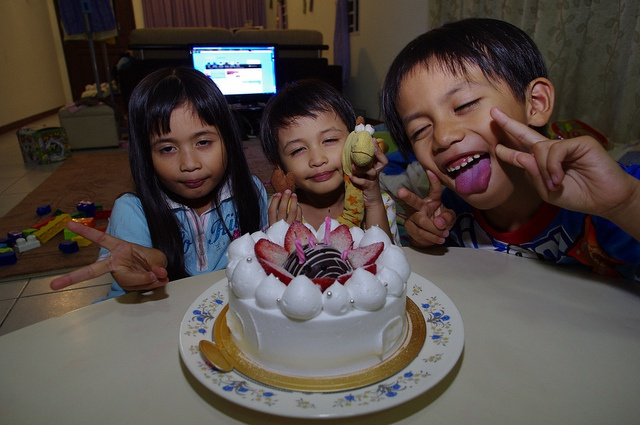Describe the objects in this image and their specific colors. I can see dining table in maroon, gray, black, and olive tones, people in maroon, black, gray, and brown tones, people in maroon, black, and gray tones, cake in maroon, darkgray, and gray tones, and people in maroon, black, gray, and brown tones in this image. 